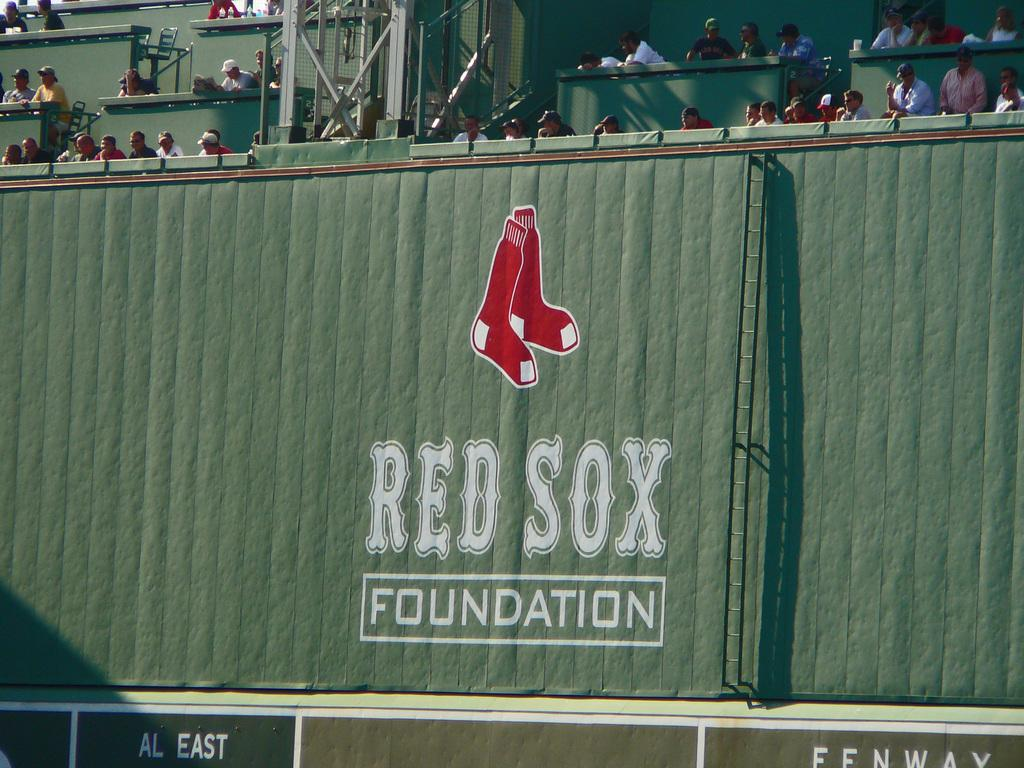<image>
Write a terse but informative summary of the picture. The Red Sox Foundation on the Green Monster at Fenway Park. 